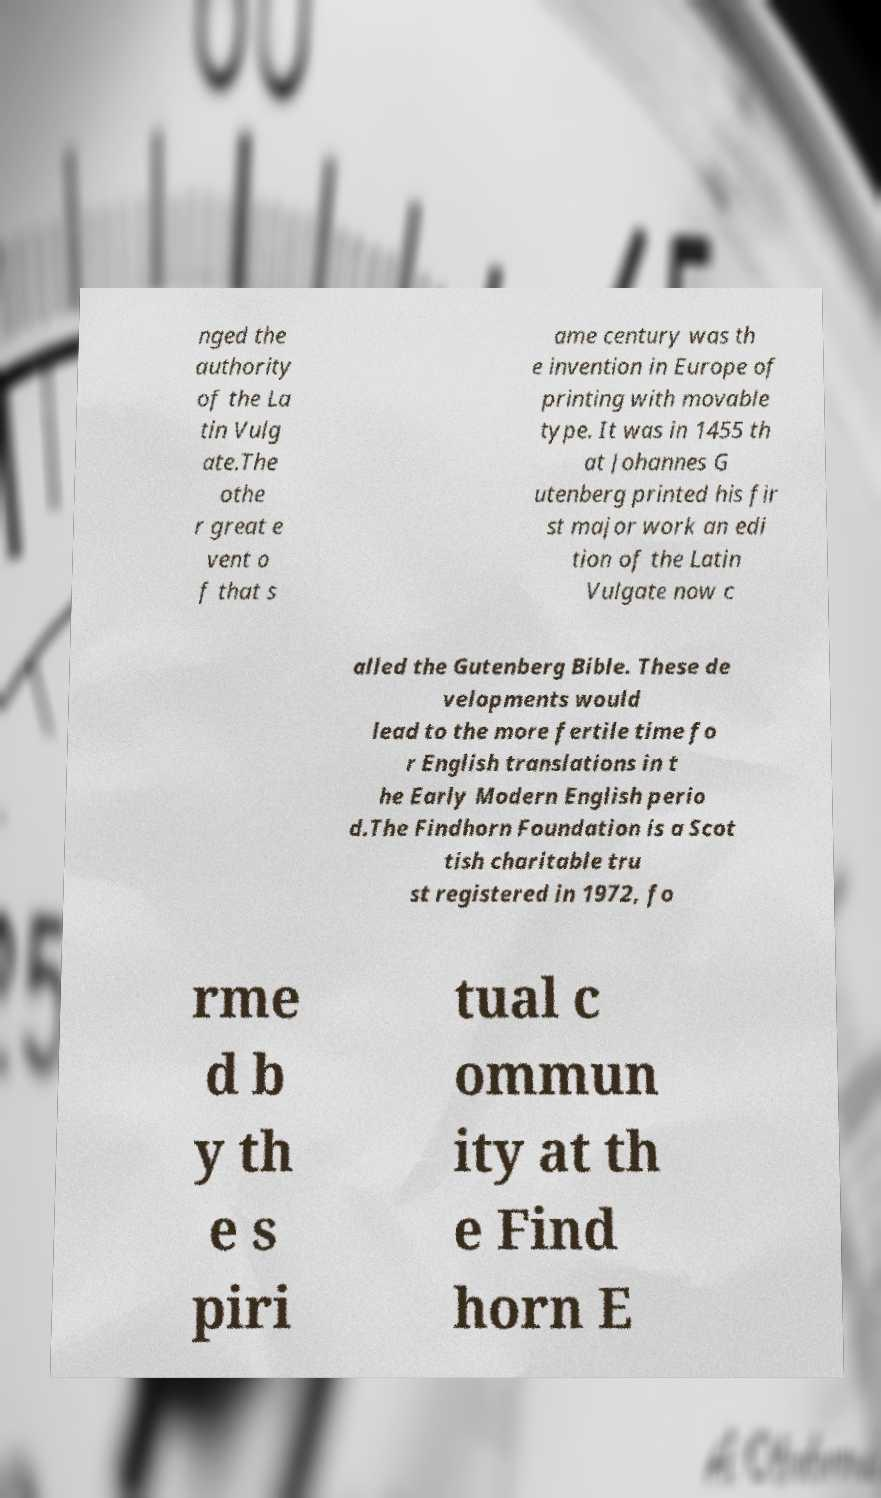Could you extract and type out the text from this image? nged the authority of the La tin Vulg ate.The othe r great e vent o f that s ame century was th e invention in Europe of printing with movable type. It was in 1455 th at Johannes G utenberg printed his fir st major work an edi tion of the Latin Vulgate now c alled the Gutenberg Bible. These de velopments would lead to the more fertile time fo r English translations in t he Early Modern English perio d.The Findhorn Foundation is a Scot tish charitable tru st registered in 1972, fo rme d b y th e s piri tual c ommun ity at th e Find horn E 